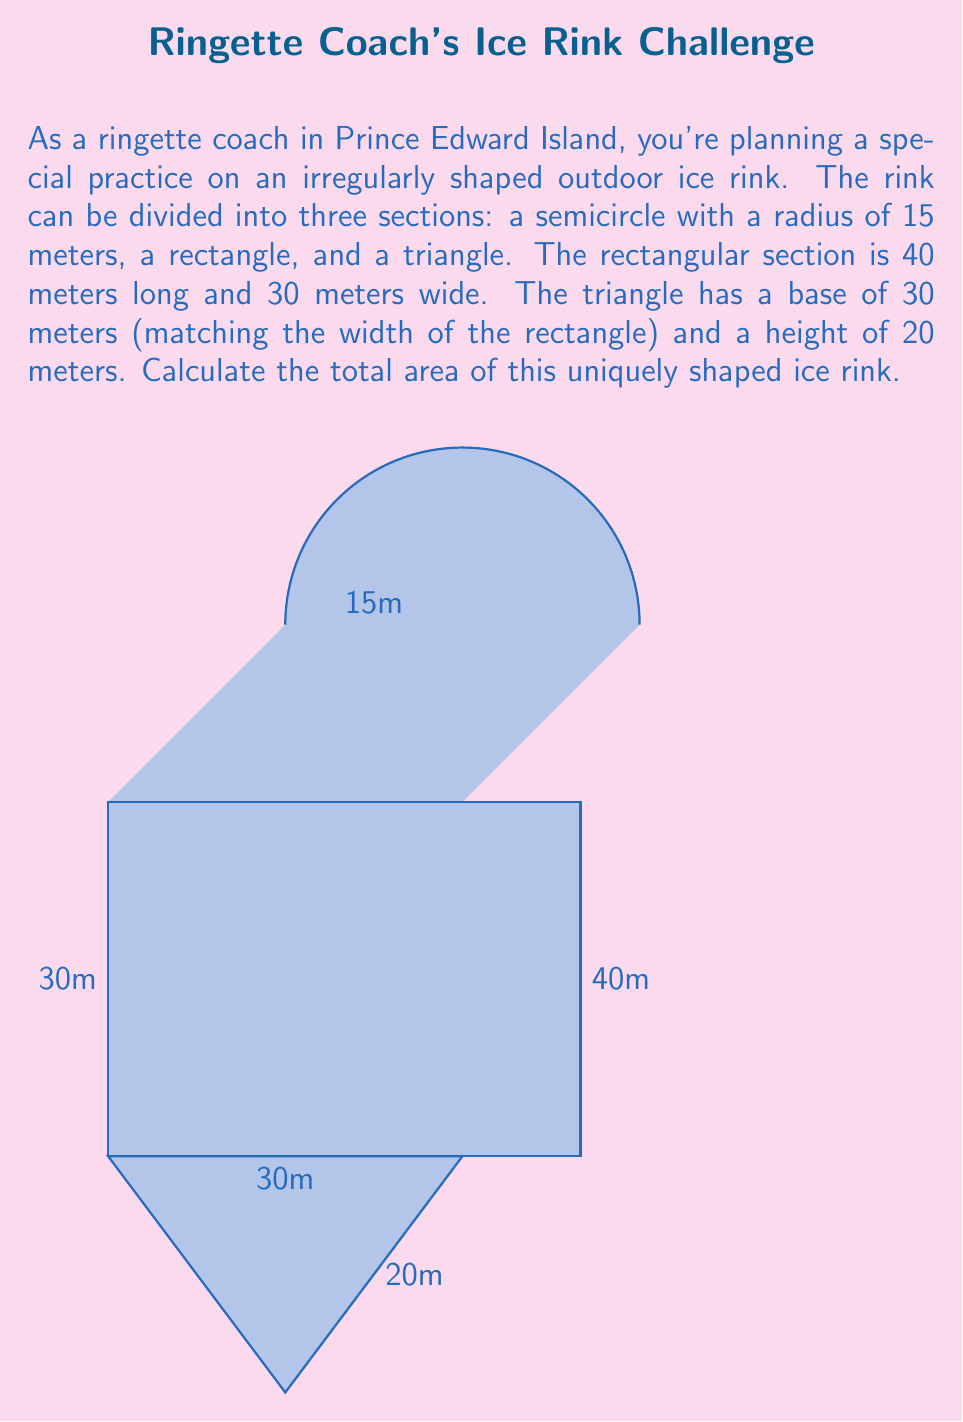Teach me how to tackle this problem. Let's calculate the area of each section separately and then sum them up:

1. Semicircle area:
   The area of a semicircle is given by the formula: $A = \frac{1}{2} \pi r^2$
   $$A_{semicircle} = \frac{1}{2} \pi (15\text{m})^2 = \frac{1}{2} \pi (225\text{m}^2) = 112.5\pi \text{ m}^2$$

2. Rectangle area:
   The area of a rectangle is length times width
   $$A_{rectangle} = 40\text{m} \times 30\text{m} = 1200 \text{ m}^2$$

3. Triangle area:
   The area of a triangle is $\frac{1}{2} \times base \times height$
   $$A_{triangle} = \frac{1}{2} \times 30\text{m} \times 20\text{m} = 300 \text{ m}^2$$

4. Total area:
   Sum up all three areas
   $$A_{total} = A_{semicircle} + A_{rectangle} + A_{triangle}$$
   $$A_{total} = 112.5\pi \text{ m}^2 + 1200 \text{ m}^2 + 300 \text{ m}^2$$
   $$A_{total} = 112.5\pi \text{ m}^2 + 1500 \text{ m}^2$$
   $$A_{total} \approx 1853.54 \text{ m}^2$$
Answer: $1853.54 \text{ m}^2$ 